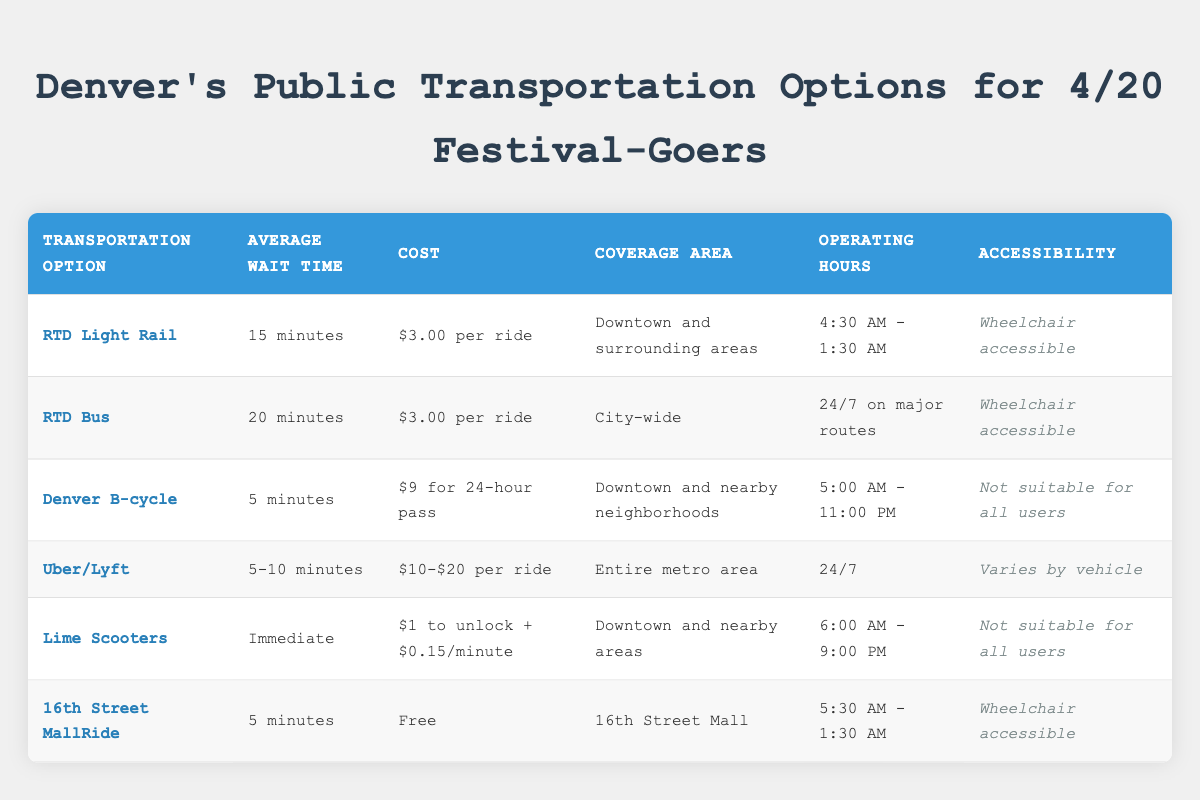What is the cost of using RTD Light Rail? The table shows the cost for RTD Light Rail is listed under the "Cost" column, which states "$3.00 per ride."
Answer: $3.00 per ride What is the average wait time for Denver B-cycle? According to the table, the average wait time for Denver B-cycle is located in the "Average Wait Time" column, which indicates "5 minutes."
Answer: 5 minutes Is the Uber/Lyft option wheelchair accessible? The table specifies the accessibility feature for Uber/Lyft in the "Accessibility" column, which shows "Varies by vehicle." Since this is not explicitly wheelchair accessible, the answer is no.
Answer: No How long do the Lime Scooters operate each day? The "Operating Hours" column for Lime Scooters indicates that they operate from "6:00 AM - 9:00 PM." This shows they are available for a total of 15 hours each day.
Answer: 15 hours What is the total cost for a 24-hour pass on Denver B-cycle compared to a single ride on RTD Light Rail? The cost for a Denver B-cycle is "$9 for 24-hour pass," while the cost of RTD Light Rail is "$3.00 per ride." Compared to the single ride, the 24-hour pass is a better deal if you plan multiple rides.
Answer: 24-hour pass is $9, single ride is $3.00 What is the difference in average wait time between RTD Bus and 16th Street MallRide? The average wait time for RTD Bus is "20 minutes," and for 16th Street MallRide, it is "5 minutes." The difference is 20 - 5 = 15 minutes.
Answer: 15 minutes Which transportation option has the longest operating hours? The table shows that the RTD Bus operates "24/7 on major routes," which is the longest operating schedule compared to others with specific time frames.
Answer: RTD Bus How many options are available that are wheelchair accessible? By reviewing the "Accessibility" column, RTD Light Rail, RTD Bus, and 16th Street MallRide are marked as wheelchair accessible, making a total of three options.
Answer: 3 options What transportation option provides immediate availability? The "Average Wait Time" column shows that Lime Scooters have "Immediate" availability, meaning you can use them right away as soon as you find one.
Answer: Lime Scooters 